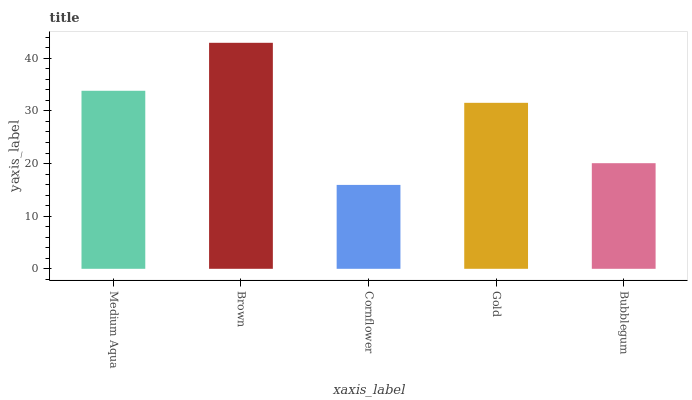Is Cornflower the minimum?
Answer yes or no. Yes. Is Brown the maximum?
Answer yes or no. Yes. Is Brown the minimum?
Answer yes or no. No. Is Cornflower the maximum?
Answer yes or no. No. Is Brown greater than Cornflower?
Answer yes or no. Yes. Is Cornflower less than Brown?
Answer yes or no. Yes. Is Cornflower greater than Brown?
Answer yes or no. No. Is Brown less than Cornflower?
Answer yes or no. No. Is Gold the high median?
Answer yes or no. Yes. Is Gold the low median?
Answer yes or no. Yes. Is Bubblegum the high median?
Answer yes or no. No. Is Cornflower the low median?
Answer yes or no. No. 